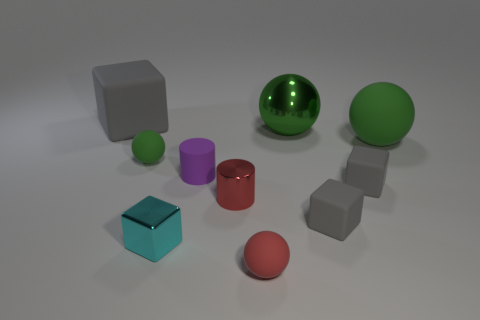Is there anything else that has the same color as the small matte cylinder?
Your response must be concise. No. What number of metal things are purple cylinders or brown things?
Your answer should be compact. 0. What is the material of the purple object?
Provide a short and direct response. Rubber. There is a red rubber thing; how many gray rubber blocks are left of it?
Your answer should be very brief. 1. Does the big thing on the left side of the red ball have the same material as the small green sphere?
Ensure brevity in your answer.  Yes. How many other large things have the same shape as the purple rubber thing?
Provide a succinct answer. 0. How many large things are cyan metallic objects or blue blocks?
Provide a succinct answer. 0. Does the tiny rubber sphere behind the red matte ball have the same color as the big block?
Your answer should be very brief. No. Do the rubber sphere that is right of the red rubber object and the small rubber sphere that is behind the red cylinder have the same color?
Ensure brevity in your answer.  Yes. Is there a small red cylinder made of the same material as the cyan object?
Provide a succinct answer. Yes. 